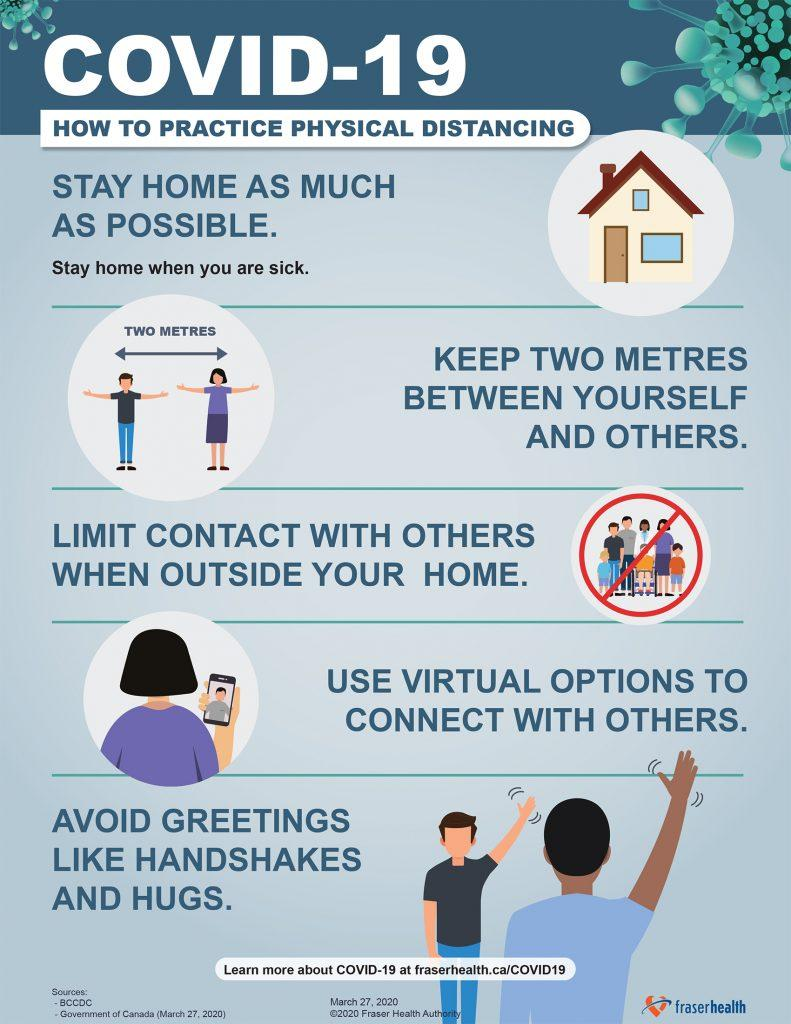List a handful of essential elements in this visual. Effective measures to prevent the spread of COVID-19, including maintaining a minimum safe distance of two meters between individuals, have been put in place to ensure public health and safety. 